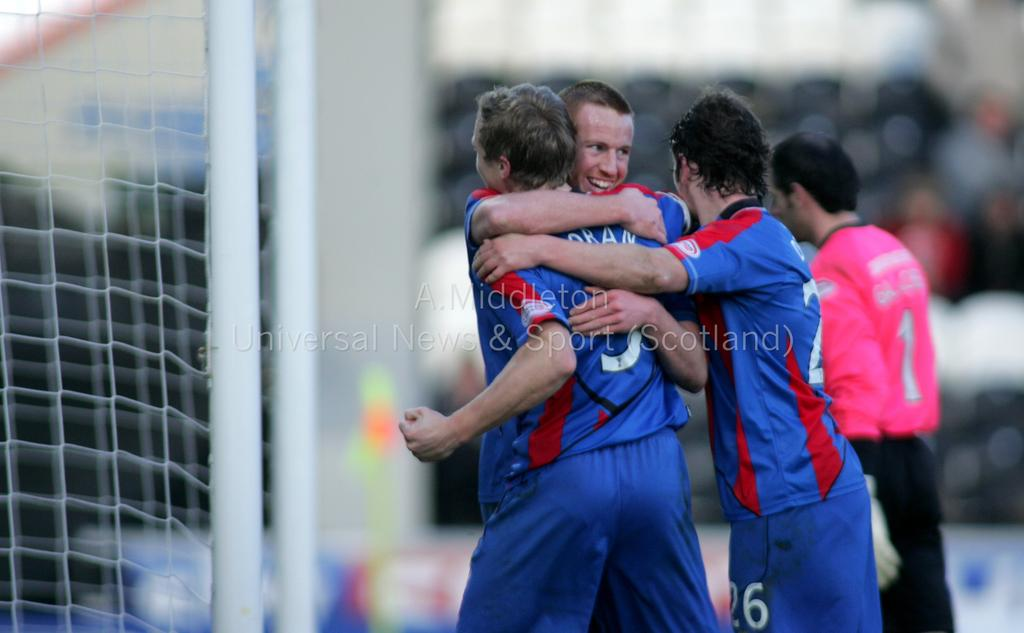<image>
Share a concise interpretation of the image provided. Number 1 of the pink team walks away as the blue team celebrates. 